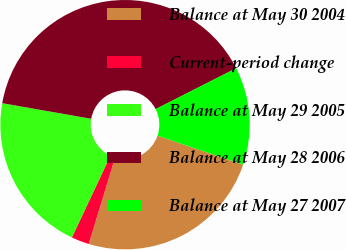<chart> <loc_0><loc_0><loc_500><loc_500><pie_chart><fcel>Balance at May 30 2004<fcel>Current-period change<fcel>Balance at May 29 2005<fcel>Balance at May 28 2006<fcel>Balance at May 27 2007<nl><fcel>24.5%<fcel>2.31%<fcel>20.75%<fcel>39.77%<fcel>12.68%<nl></chart> 